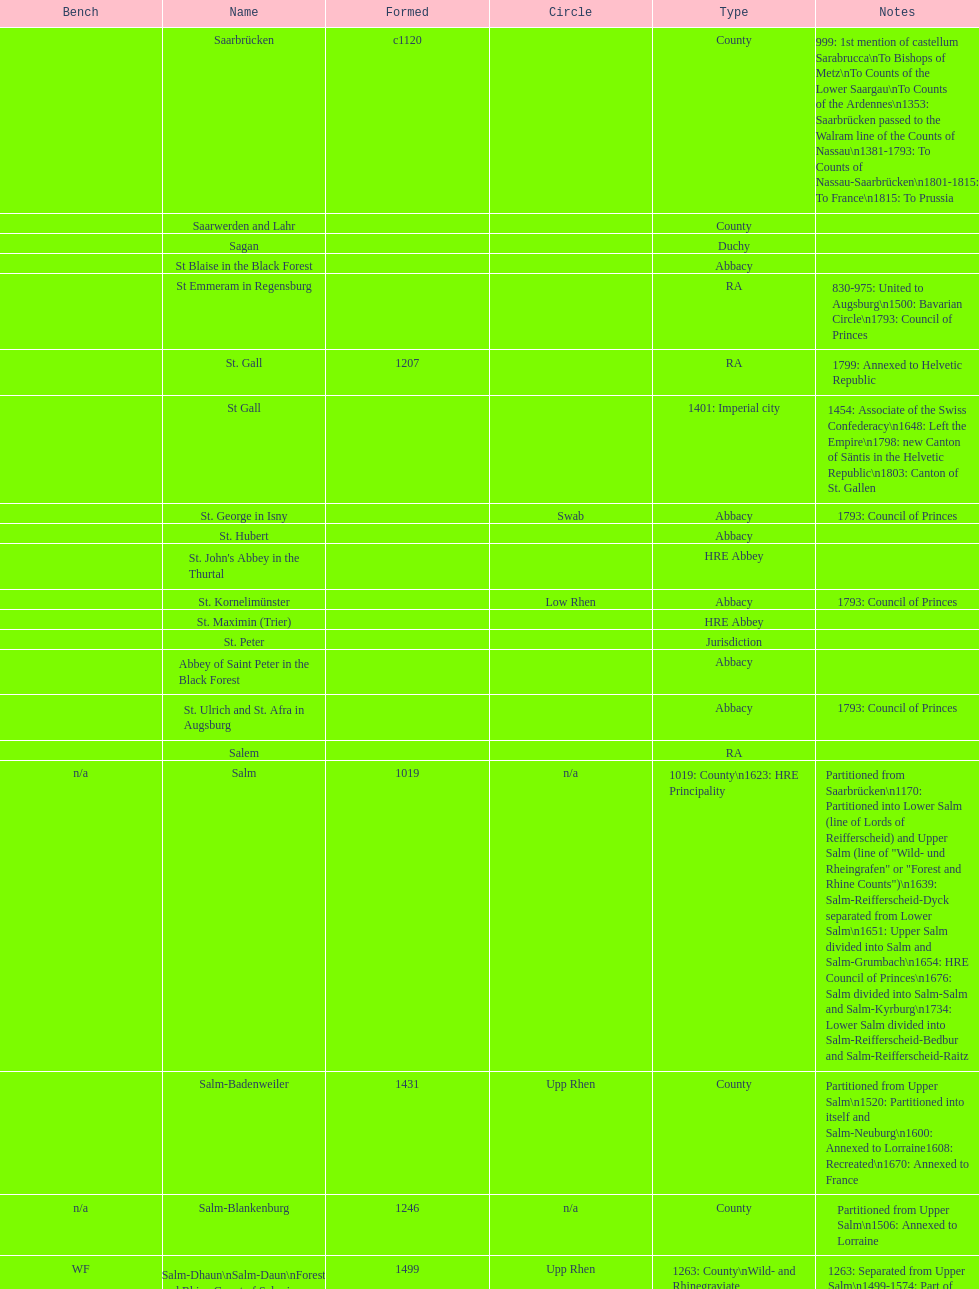How many states were of the same type as stuhlingen? 3. 